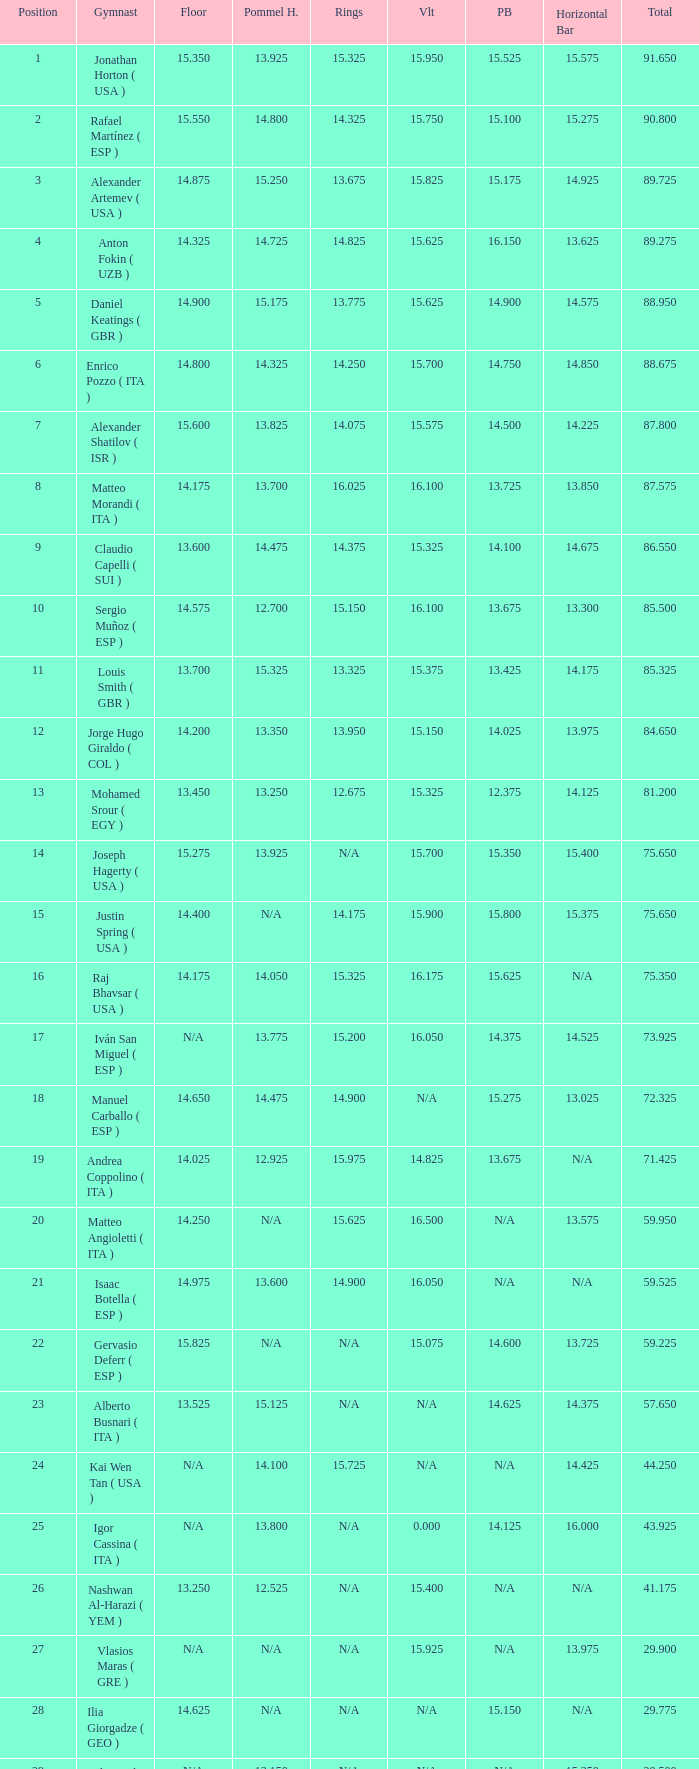If the horizontal bar is n/a and the floor is 14.175, what is the number for the parallel bars? 15.625. 